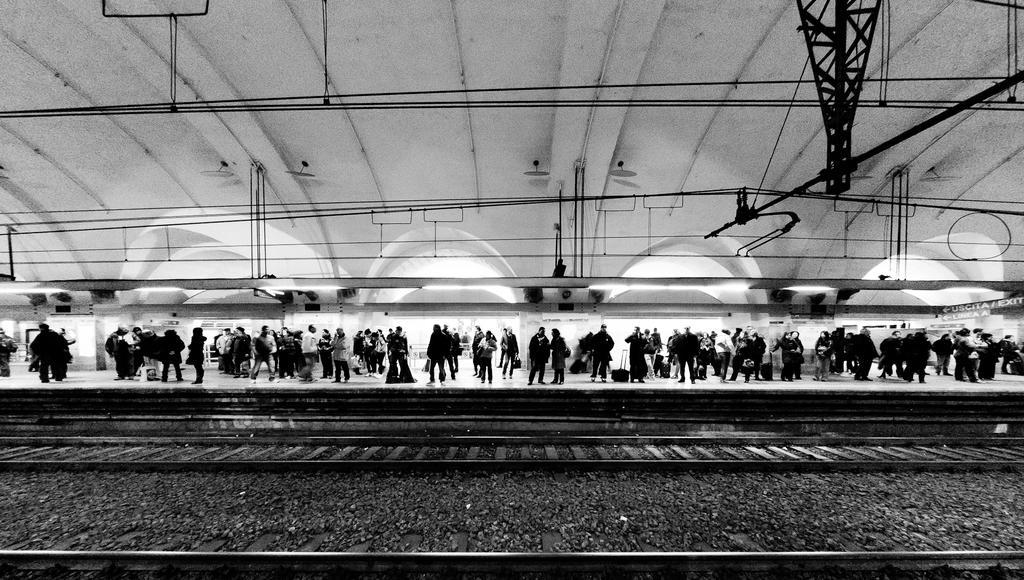Describe this image in one or two sentences. In this image I can see the tracks. In the background I can see many people are standing on the platform. I can see the wires and metal rods at the top. I can see this is a black and white image. 